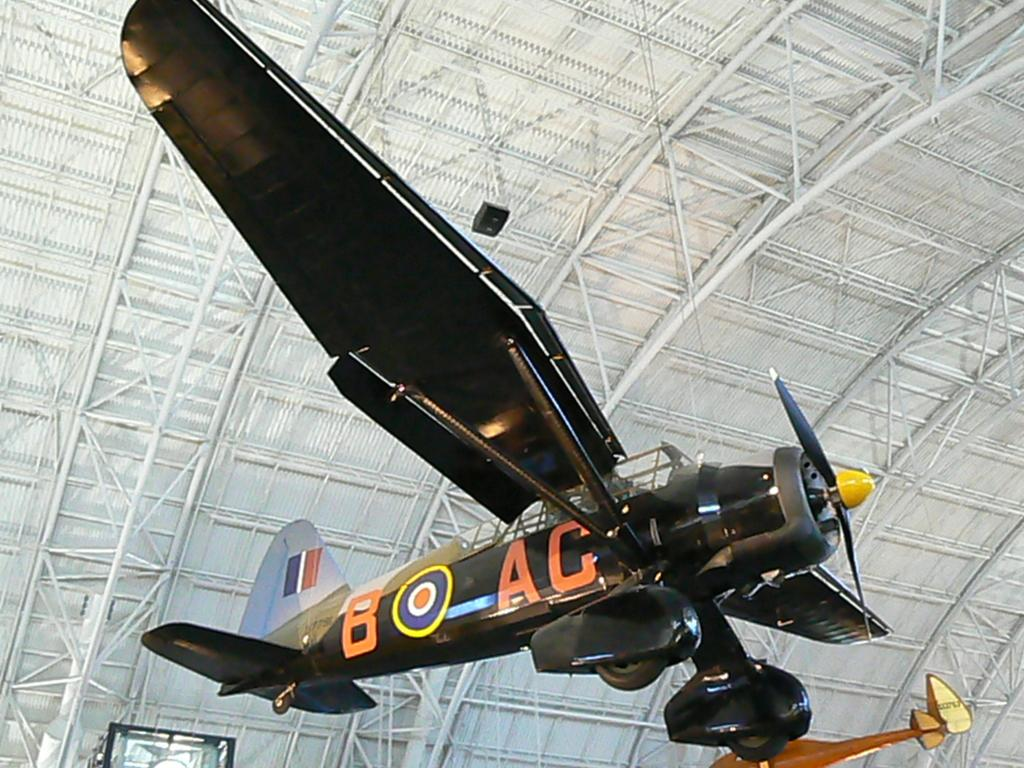<image>
Provide a brief description of the given image. An aircraft labelled as B AC hanging from the roof of a hanger. 